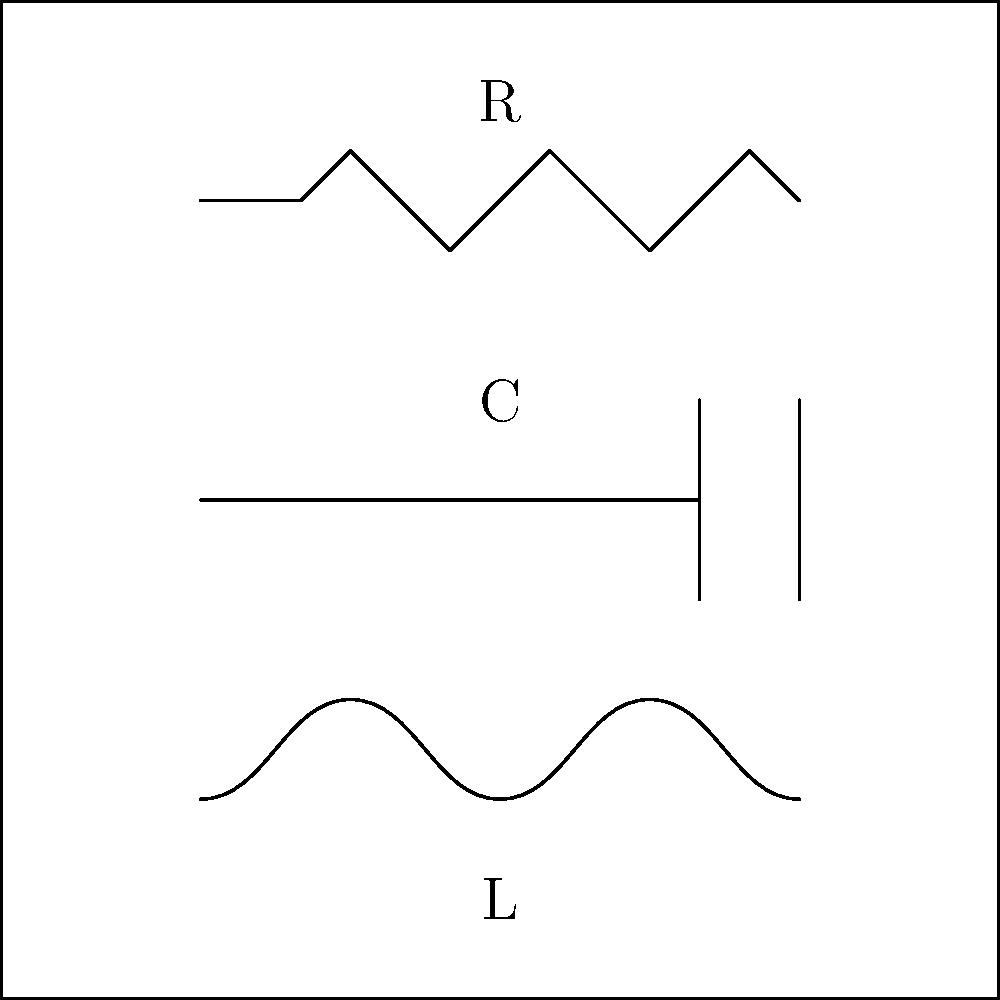In the circuit diagram above, identify the electrical components represented by the symbols labeled R, C, and L. How might these components be used in a simple electronic device that Dianne Marie Andre's protagonist could carry while exploring the bustling city? Let's break down the circuit diagram and identify each component:

1. Symbol R: This is a zigzag line, which represents a resistor. Resistors are used to control current flow in a circuit.

2. Symbol C: This symbol shows two parallel lines, which represents a capacitor. Capacitors store and release electrical energy.

3. Symbol L: This is a curved line with multiple loops, which represents an inductor. Inductors store energy in a magnetic field.

These components could be used in a simple electronic device like a portable radio or e-reader that Dianne Marie Andre's protagonist might carry while exploring the city:

- Resistors (R) could be used to control the volume in a radio or adjust the screen brightness in an e-reader.
- Capacitors (C) might be used in the power supply to smooth out voltage fluctuations, ensuring stable operation of the device.
- Inductors (L) could be part of the radio's tuning circuit, helping to select specific frequencies.

Understanding these basic components is crucial for aspiring writers who want to accurately describe technology in their stories, adding authenticity to their work.
Answer: R: Resistor, C: Capacitor, L: Inductor 